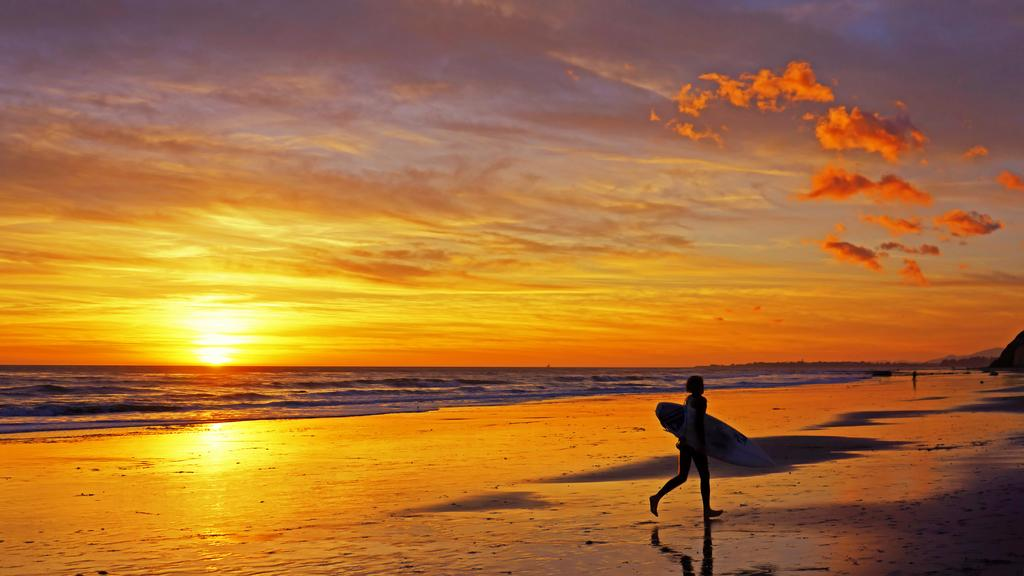Who is present in the image? There is a person in the image. What is the person holding in the image? The person is holding a surfing board. Where is the person located in the image? The person is walking on the sea shore. What can be seen in the background of the image? There is water and sky visible in the image. What is the sky's condition in the image? The sky has clouds and the sun is visible. How many geese are flying over the person in the image? There are no geese present in the image. What type of whistle is the person using while walking on the sea shore? There is no whistle present in the image, and the person is not using one. 